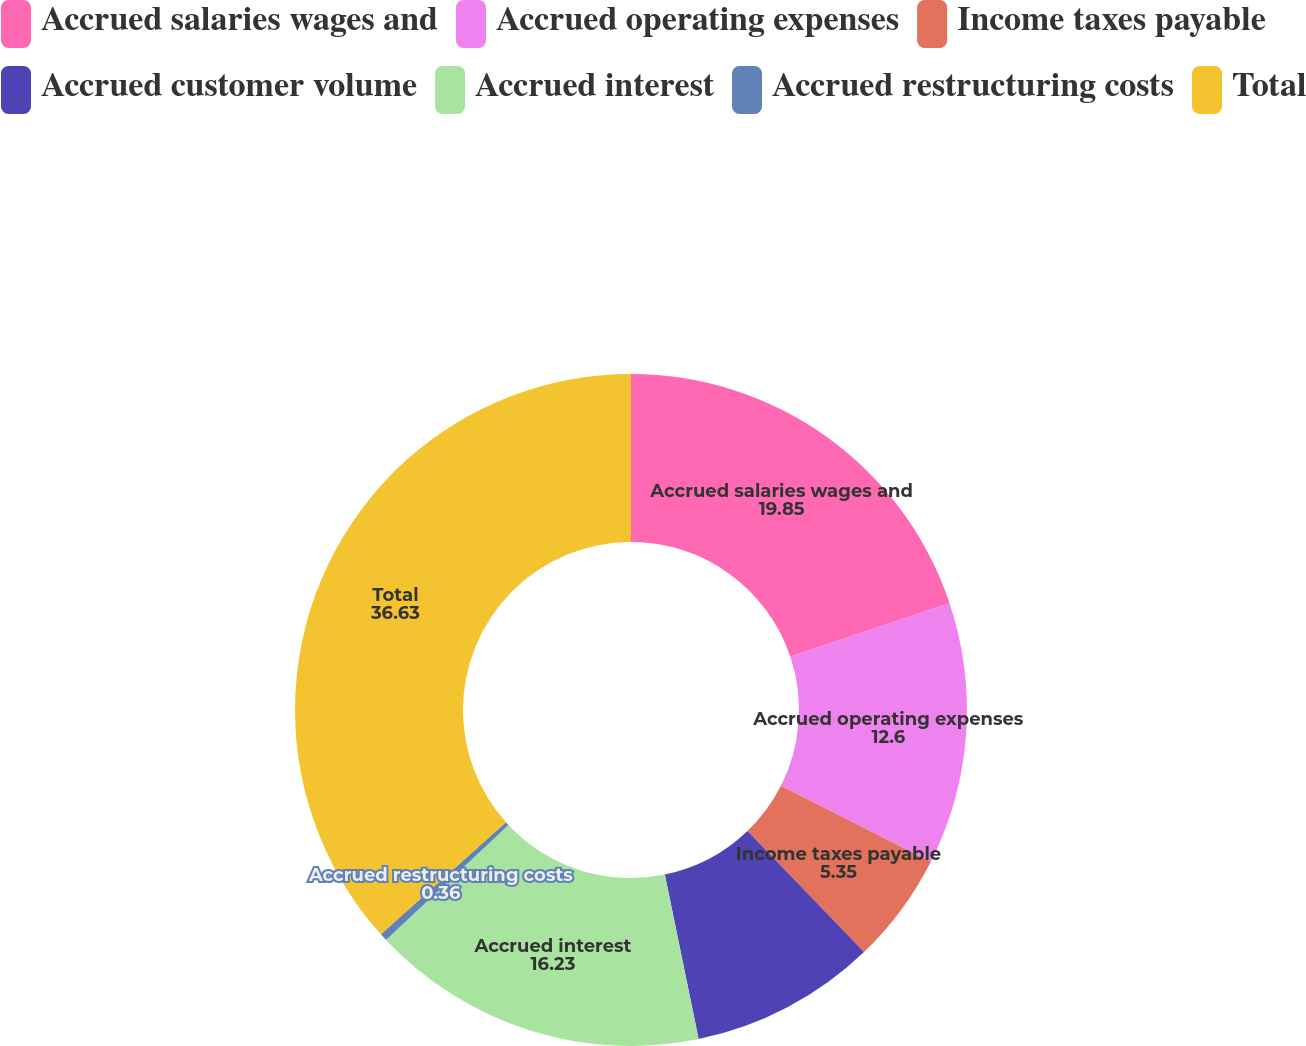Convert chart to OTSL. <chart><loc_0><loc_0><loc_500><loc_500><pie_chart><fcel>Accrued salaries wages and<fcel>Accrued operating expenses<fcel>Income taxes payable<fcel>Accrued customer volume<fcel>Accrued interest<fcel>Accrued restructuring costs<fcel>Total<nl><fcel>19.85%<fcel>12.6%<fcel>5.35%<fcel>8.97%<fcel>16.23%<fcel>0.36%<fcel>36.63%<nl></chart> 